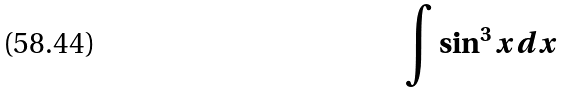<formula> <loc_0><loc_0><loc_500><loc_500>\int \sin ^ { 3 } x d x</formula> 